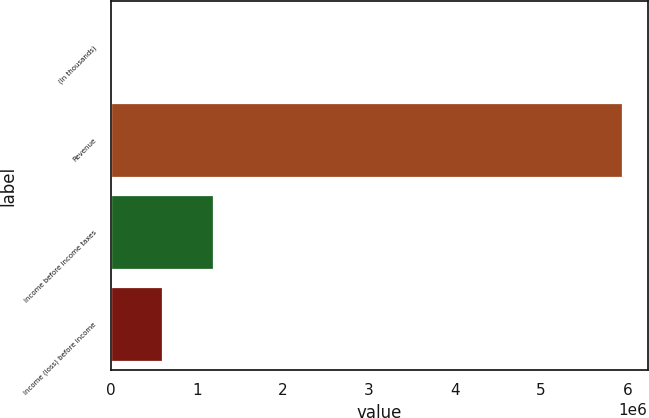Convert chart. <chart><loc_0><loc_0><loc_500><loc_500><bar_chart><fcel>(In thousands)<fcel>Revenue<fcel>Income before income taxes<fcel>Income (loss) before income<nl><fcel>2015<fcel>5.93844e+06<fcel>1.1893e+06<fcel>595658<nl></chart> 